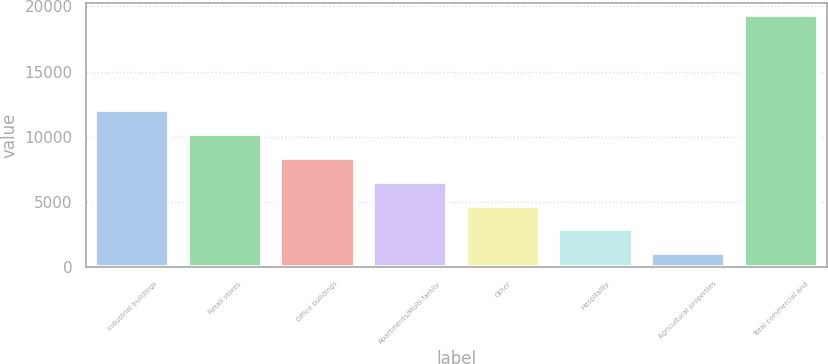Convert chart to OTSL. <chart><loc_0><loc_0><loc_500><loc_500><bar_chart><fcel>Industrial buildings<fcel>Retail stores<fcel>Office buildings<fcel>Apartments/Multi-family<fcel>Other<fcel>Hospitality<fcel>Agricultural properties<fcel>Total commercial and<nl><fcel>12025.6<fcel>10201.5<fcel>8377.4<fcel>6553.3<fcel>4729.2<fcel>2905.1<fcel>1081<fcel>19322<nl></chart> 